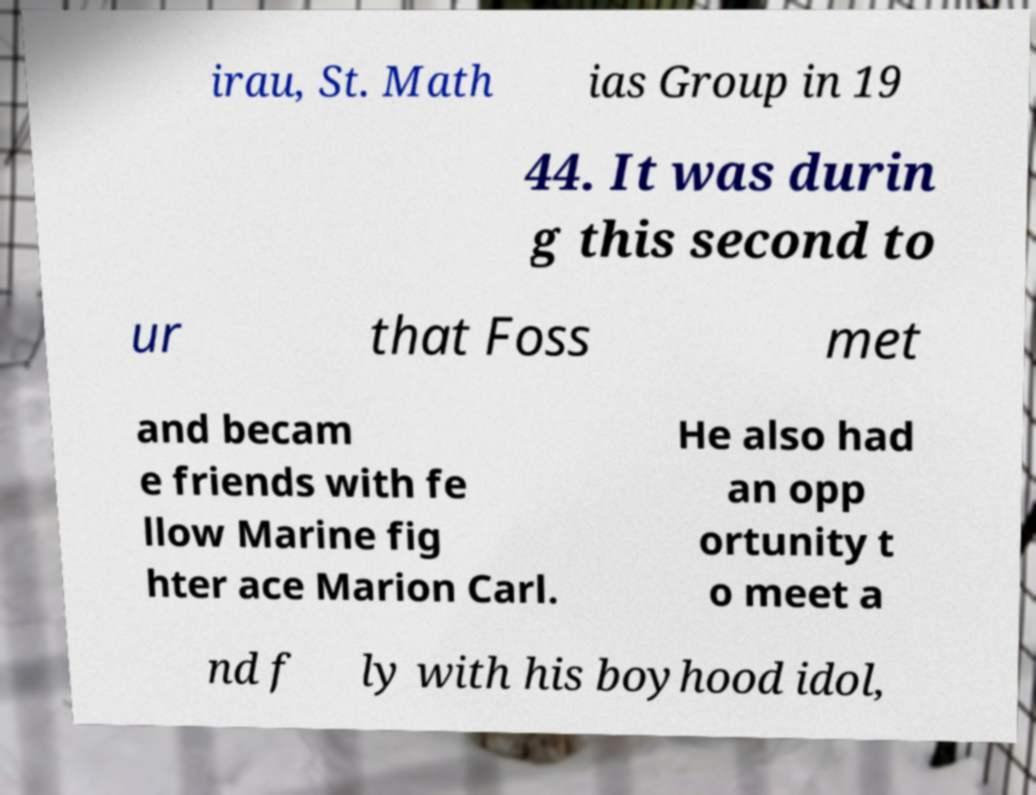I need the written content from this picture converted into text. Can you do that? irau, St. Math ias Group in 19 44. It was durin g this second to ur that Foss met and becam e friends with fe llow Marine fig hter ace Marion Carl. He also had an opp ortunity t o meet a nd f ly with his boyhood idol, 